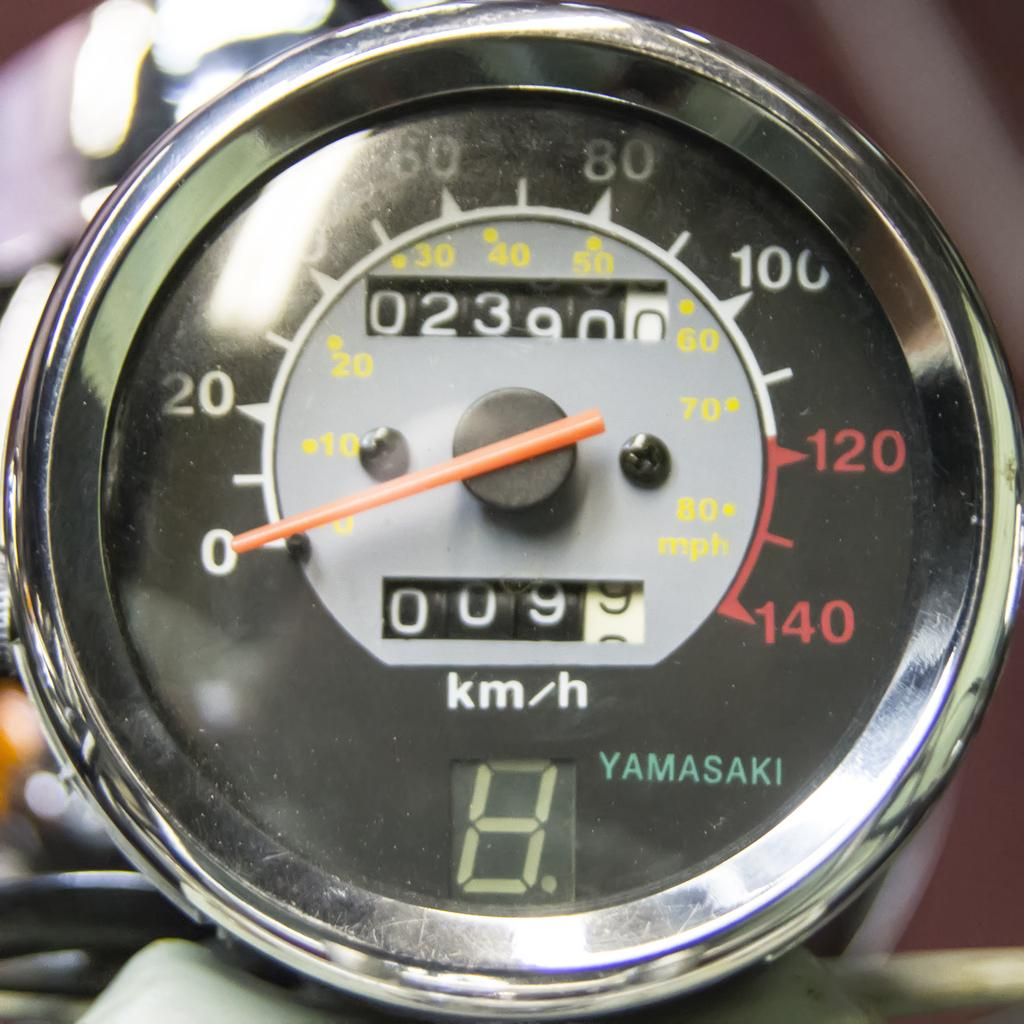<image>
Describe the image concisely. A gauge that appears to have been manufactured by the Yamasaki company. 